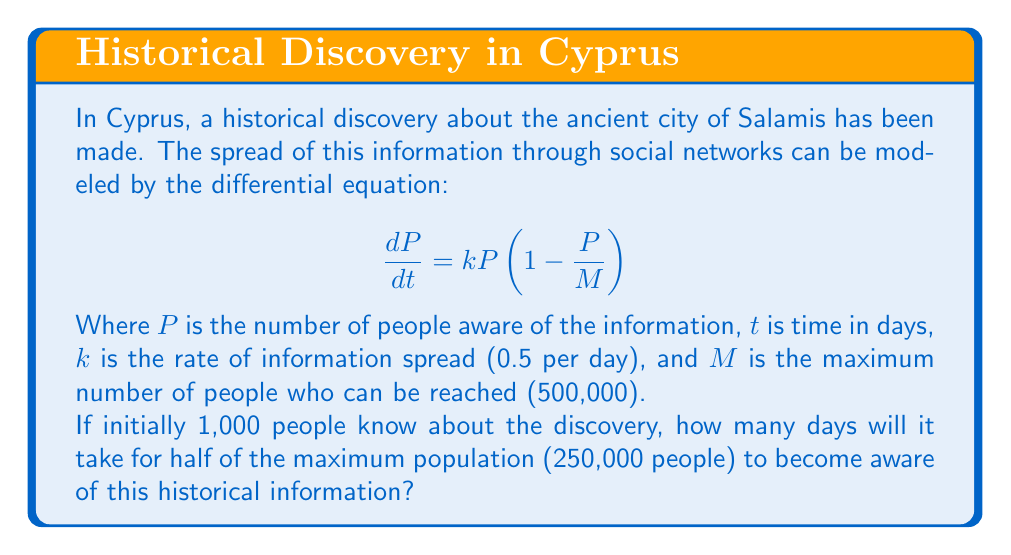Can you answer this question? To solve this problem, we'll use the logistic growth model and its solution:

1) The solution to the logistic differential equation is:

   $$P(t) = \frac{MP_0e^{kt}}{M + P_0(e^{kt} - 1)}$$

   Where $P_0$ is the initial population (1,000 in this case).

2) We want to find $t$ when $P(t) = 250,000$ (half of $M$).

3) Substituting the values:

   $$250,000 = \frac{500,000 \cdot 1,000 \cdot e^{0.5t}}{500,000 + 1,000(e^{0.5t} - 1)}$$

4) Simplifying:

   $$250,000 = \frac{500,000,000 \cdot e^{0.5t}}{500,000 + 1,000e^{0.5t} - 1,000}$$

5) Multiply both sides by the denominator:

   $$125,000,000,000 + 250,000,000e^{0.5t} - 250,000,000 = 500,000,000 \cdot e^{0.5t}$$

6) Simplify:

   $$124,750,000,000 = 250,000,000e^{0.5t}$$

7) Divide both sides by 250,000,000:

   $$499 = e^{0.5t}$$

8) Take the natural log of both sides:

   $$\ln(499) = 0.5t$$

9) Solve for $t$:

   $$t = \frac{2\ln(499)}{0.5} \approx 12.43$$

Therefore, it will take approximately 12.43 days for half of the maximum population to become aware of the historical information about Salamis.
Answer: $12.43$ days 